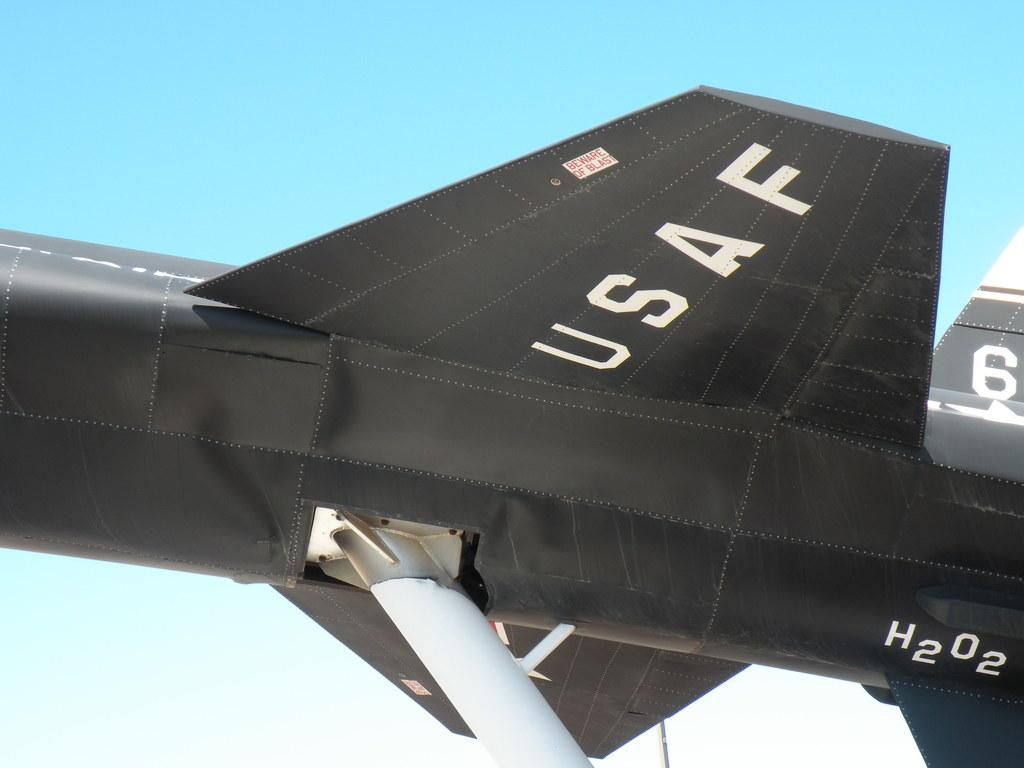What is the main subject of the image? The main subject of the image is an aircraft. What color is the aircraft? The aircraft is black in color. What can be seen in the background of the image? The sky is visible in the background of the image. Are there any markings or text on the aircraft? Yes, there is text on the aircraft. What flavor of ice cream is being served in the basin on the aircraft? There is no ice cream or basin present in the image. The aircraft is black, and there is text on it. Can you see a hook attached to the aircraft in the image? There is no hook visible in the image; it only shows an aircraft with text on it and a visible sky in the background. 